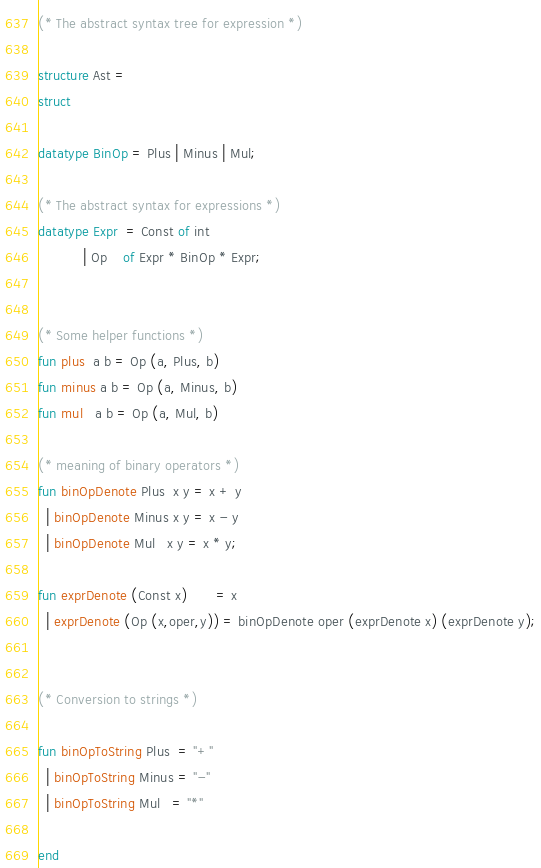<code> <loc_0><loc_0><loc_500><loc_500><_SML_>(* The abstract syntax tree for expression *)

structure Ast =
struct

datatype BinOp = Plus | Minus | Mul;

(* The abstract syntax for expressions *)
datatype Expr  = Const of int
	       | Op    of Expr * BinOp * Expr;


(* Some helper functions *)
fun plus  a b = Op (a, Plus, b)
fun minus a b = Op (a, Minus, b)
fun mul   a b = Op (a, Mul, b)

(* meaning of binary operators *)
fun binOpDenote Plus  x y = x + y
  | binOpDenote Minus x y = x - y
  | binOpDenote Mul   x y = x * y;

fun exprDenote (Const x)       = x
  | exprDenote (Op (x,oper,y)) = binOpDenote oper (exprDenote x) (exprDenote y);


(* Conversion to strings *)

fun binOpToString Plus  = "+"
  | binOpToString Minus = "-"
  | binOpToString Mul   = "*"

end
</code> 